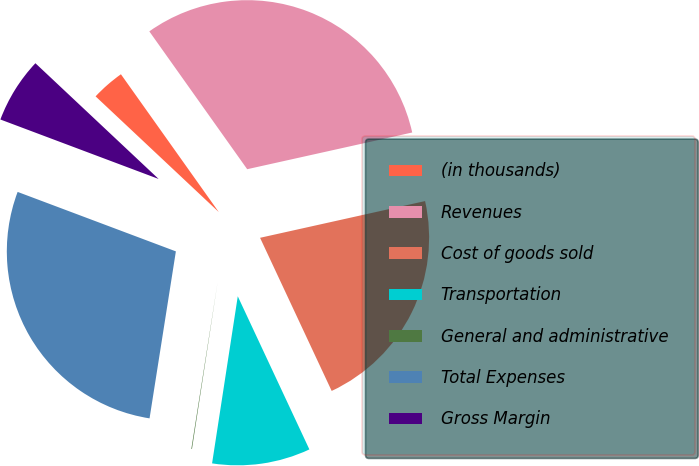Convert chart to OTSL. <chart><loc_0><loc_0><loc_500><loc_500><pie_chart><fcel>(in thousands)<fcel>Revenues<fcel>Cost of goods sold<fcel>Transportation<fcel>General and administrative<fcel>Total Expenses<fcel>Gross Margin<nl><fcel>3.17%<fcel>31.34%<fcel>21.52%<fcel>9.39%<fcel>0.06%<fcel>28.23%<fcel>6.28%<nl></chart> 